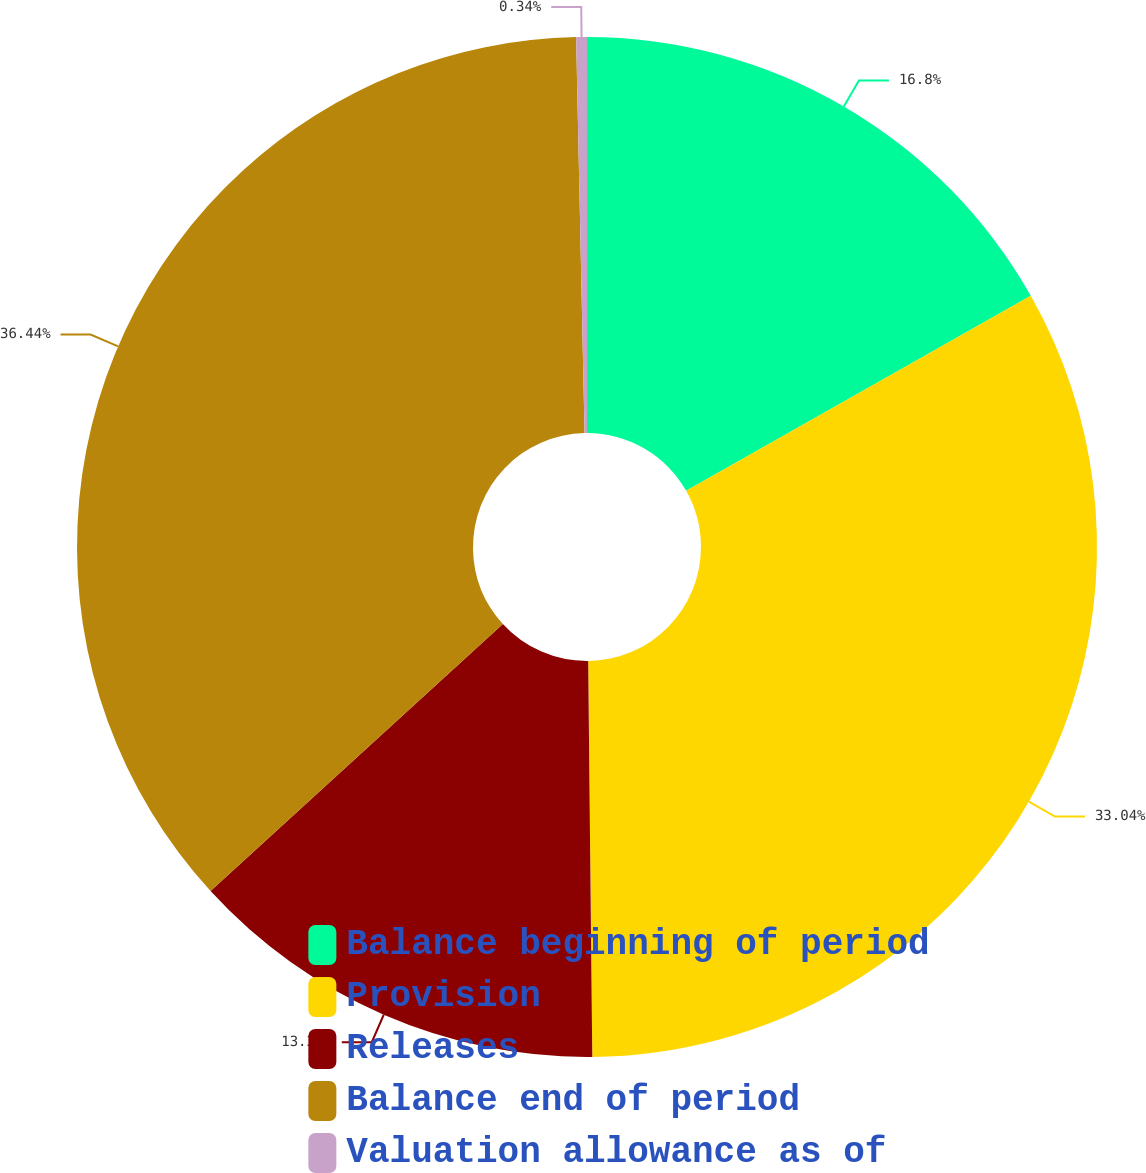Convert chart. <chart><loc_0><loc_0><loc_500><loc_500><pie_chart><fcel>Balance beginning of period<fcel>Provision<fcel>Releases<fcel>Balance end of period<fcel>Valuation allowance as of<nl><fcel>16.8%<fcel>33.04%<fcel>13.38%<fcel>36.45%<fcel>0.34%<nl></chart> 